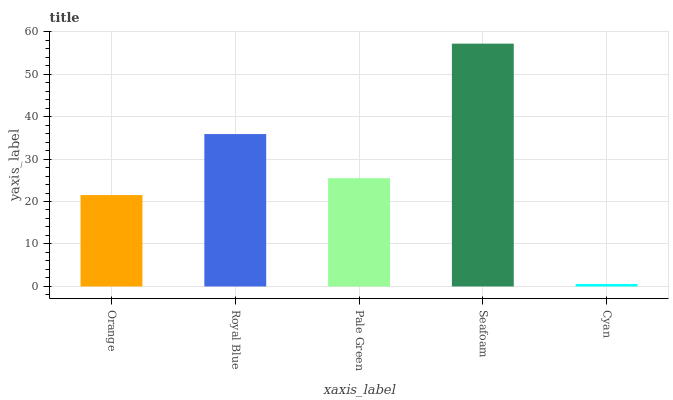Is Royal Blue the minimum?
Answer yes or no. No. Is Royal Blue the maximum?
Answer yes or no. No. Is Royal Blue greater than Orange?
Answer yes or no. Yes. Is Orange less than Royal Blue?
Answer yes or no. Yes. Is Orange greater than Royal Blue?
Answer yes or no. No. Is Royal Blue less than Orange?
Answer yes or no. No. Is Pale Green the high median?
Answer yes or no. Yes. Is Pale Green the low median?
Answer yes or no. Yes. Is Cyan the high median?
Answer yes or no. No. Is Cyan the low median?
Answer yes or no. No. 